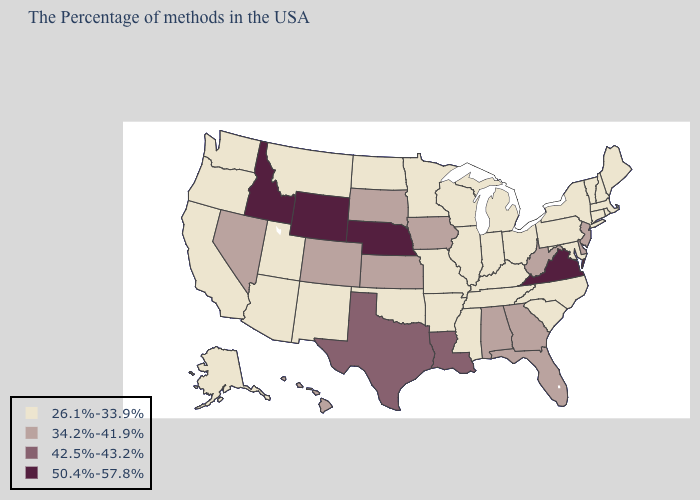Name the states that have a value in the range 50.4%-57.8%?
Give a very brief answer. Virginia, Nebraska, Wyoming, Idaho. What is the lowest value in the South?
Quick response, please. 26.1%-33.9%. What is the value of Massachusetts?
Keep it brief. 26.1%-33.9%. Which states have the lowest value in the USA?
Be succinct. Maine, Massachusetts, Rhode Island, New Hampshire, Vermont, Connecticut, New York, Maryland, Pennsylvania, North Carolina, South Carolina, Ohio, Michigan, Kentucky, Indiana, Tennessee, Wisconsin, Illinois, Mississippi, Missouri, Arkansas, Minnesota, Oklahoma, North Dakota, New Mexico, Utah, Montana, Arizona, California, Washington, Oregon, Alaska. Among the states that border West Virginia , does Ohio have the highest value?
Write a very short answer. No. What is the value of South Dakota?
Write a very short answer. 34.2%-41.9%. Does Ohio have the highest value in the USA?
Answer briefly. No. What is the value of Arkansas?
Answer briefly. 26.1%-33.9%. What is the value of Idaho?
Be succinct. 50.4%-57.8%. What is the highest value in the Northeast ?
Be succinct. 34.2%-41.9%. Does Virginia have the highest value in the South?
Be succinct. Yes. What is the lowest value in states that border Colorado?
Answer briefly. 26.1%-33.9%. Name the states that have a value in the range 26.1%-33.9%?
Keep it brief. Maine, Massachusetts, Rhode Island, New Hampshire, Vermont, Connecticut, New York, Maryland, Pennsylvania, North Carolina, South Carolina, Ohio, Michigan, Kentucky, Indiana, Tennessee, Wisconsin, Illinois, Mississippi, Missouri, Arkansas, Minnesota, Oklahoma, North Dakota, New Mexico, Utah, Montana, Arizona, California, Washington, Oregon, Alaska. Name the states that have a value in the range 34.2%-41.9%?
Be succinct. New Jersey, Delaware, West Virginia, Florida, Georgia, Alabama, Iowa, Kansas, South Dakota, Colorado, Nevada, Hawaii. Which states have the highest value in the USA?
Concise answer only. Virginia, Nebraska, Wyoming, Idaho. 